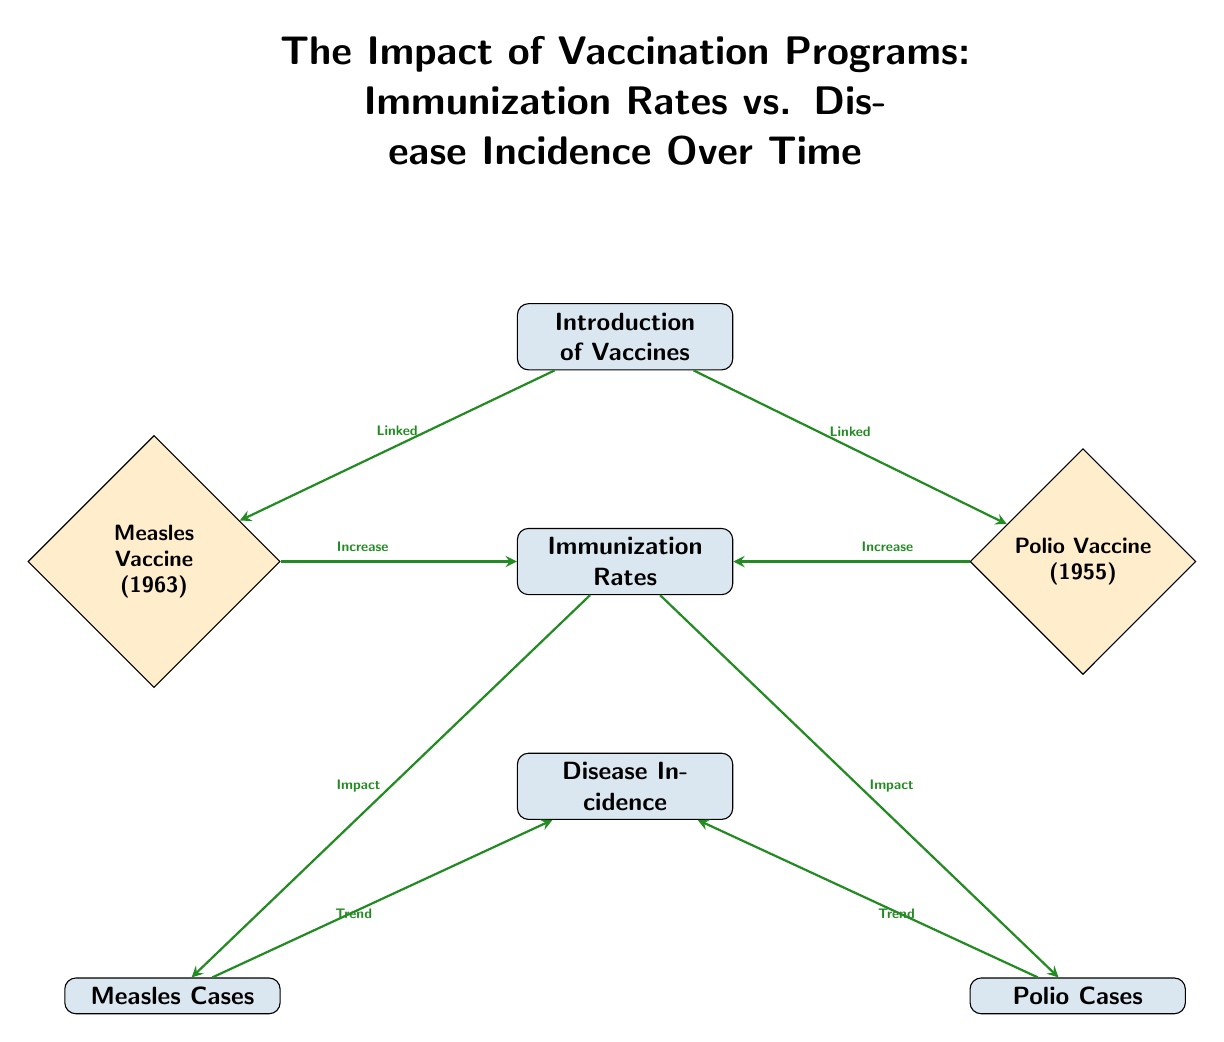What is the first node in the diagram? The diagram starts with the node titled "Introduction of Vaccines," which is positioned at the top, indicating the beginning of the vaccination program flow.
Answer: Introduction of Vaccines How many vaccine nodes are there? There are two vaccine nodes, "Measles Vaccine" and "Polio Vaccine," located on the left and right sides of the "Immunization Rates" node, respectively.
Answer: 2 What impact do immunization rates have on disease incidence? The edge connecting "Immunization Rates" to "Disease Incidence" indicates that there is an impact, implying that as immunization rates increase, disease incidence is affected as well.
Answer: Impact Which vaccine was introduced in 1963? The "Measles Vaccine," noted in the left node adjacent to "Immunization Rates," specifies it was introduced in 1963.
Answer: Measles Vaccine What is the trend relationship between measles cases and disease incidence? The connection from "Measles Cases" to "Disease Incidence" indicates a trend, suggesting that as the number of measles cases changes, it will reflect in disease incidence.
Answer: Trend How is the Measles Vaccine related to immunization rates? There is an arrow labeled "Increase" pointing from the "Measles Vaccine" node to "Immunization Rates," denoting that the introduction of the vaccine increases immunization rates.
Answer: Increase What is the relationship between polio vaccine introduction and immunization rates? The "Polio Vaccine" also has an arrow labeled "Increase" directing to "Immunization Rates," indicating that its introduction similarly boosts immunization rates.
Answer: Increase Which cases are indicated as trending towards disease incidence? Both "Measles Cases" and "Polio Cases" are indicated as having a trend connection toward "Disease Incidence," meaning they both affect the overall disease incidence measurement.
Answer: Measles Cases and Polio Cases What is the significance of the arrows in this diagram? The arrows illustrate relationships and impacts between nodes, such as how vaccine introduction influences immunization rates and subsequently trends in disease incidence.
Answer: Relationships and impacts 